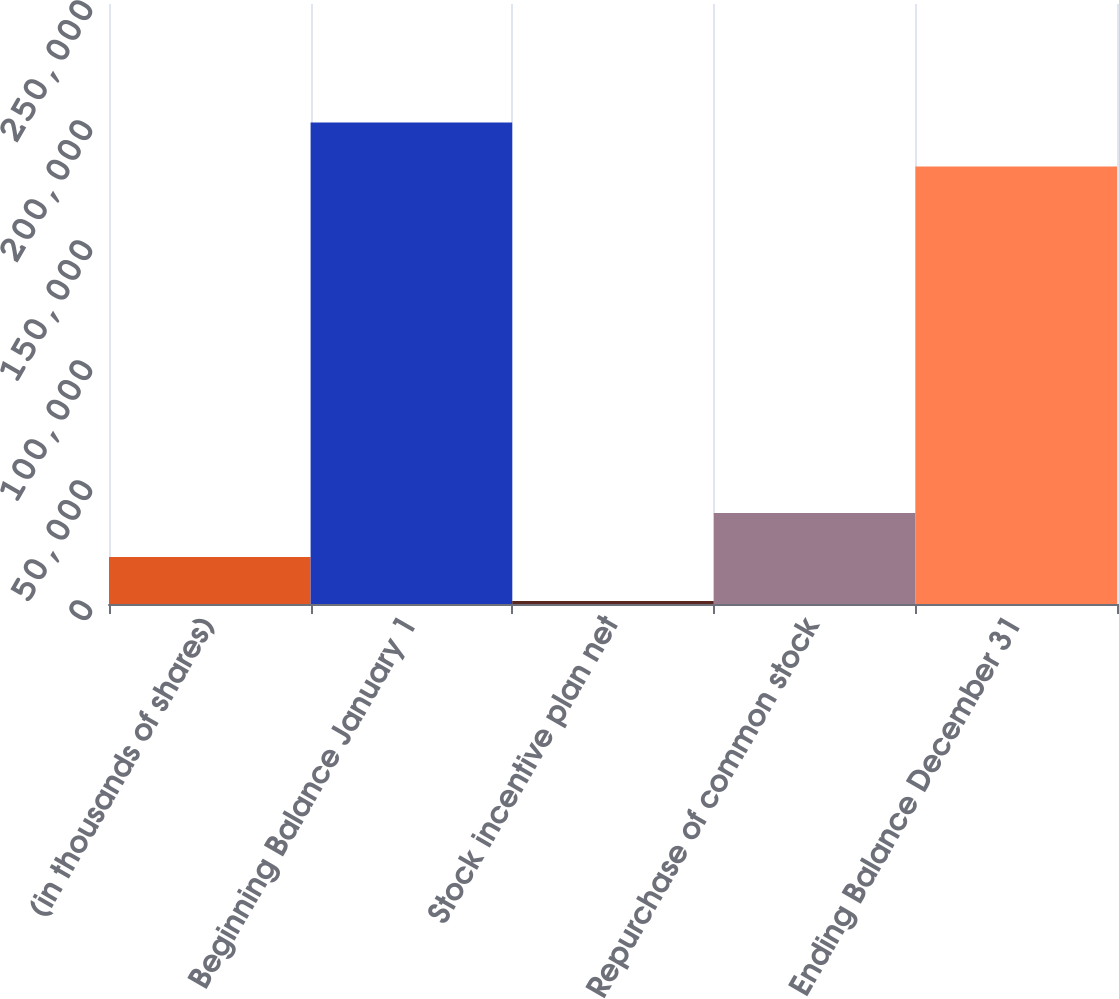<chart> <loc_0><loc_0><loc_500><loc_500><bar_chart><fcel>(in thousands of shares)<fcel>Beginning Balance January 1<fcel>Stock incentive plan net<fcel>Repurchase of common stock<fcel>Ending Balance December 31<nl><fcel>19559.1<fcel>200633<fcel>1226<fcel>37892.2<fcel>182300<nl></chart> 